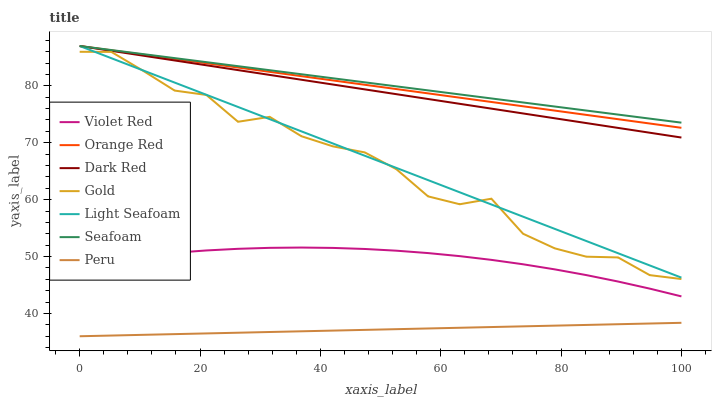Does Peru have the minimum area under the curve?
Answer yes or no. Yes. Does Seafoam have the maximum area under the curve?
Answer yes or no. Yes. Does Gold have the minimum area under the curve?
Answer yes or no. No. Does Gold have the maximum area under the curve?
Answer yes or no. No. Is Peru the smoothest?
Answer yes or no. Yes. Is Gold the roughest?
Answer yes or no. Yes. Is Dark Red the smoothest?
Answer yes or no. No. Is Dark Red the roughest?
Answer yes or no. No. Does Peru have the lowest value?
Answer yes or no. Yes. Does Gold have the lowest value?
Answer yes or no. No. Does Orange Red have the highest value?
Answer yes or no. Yes. Does Gold have the highest value?
Answer yes or no. No. Is Peru less than Gold?
Answer yes or no. Yes. Is Dark Red greater than Peru?
Answer yes or no. Yes. Does Orange Red intersect Seafoam?
Answer yes or no. Yes. Is Orange Red less than Seafoam?
Answer yes or no. No. Is Orange Red greater than Seafoam?
Answer yes or no. No. Does Peru intersect Gold?
Answer yes or no. No. 